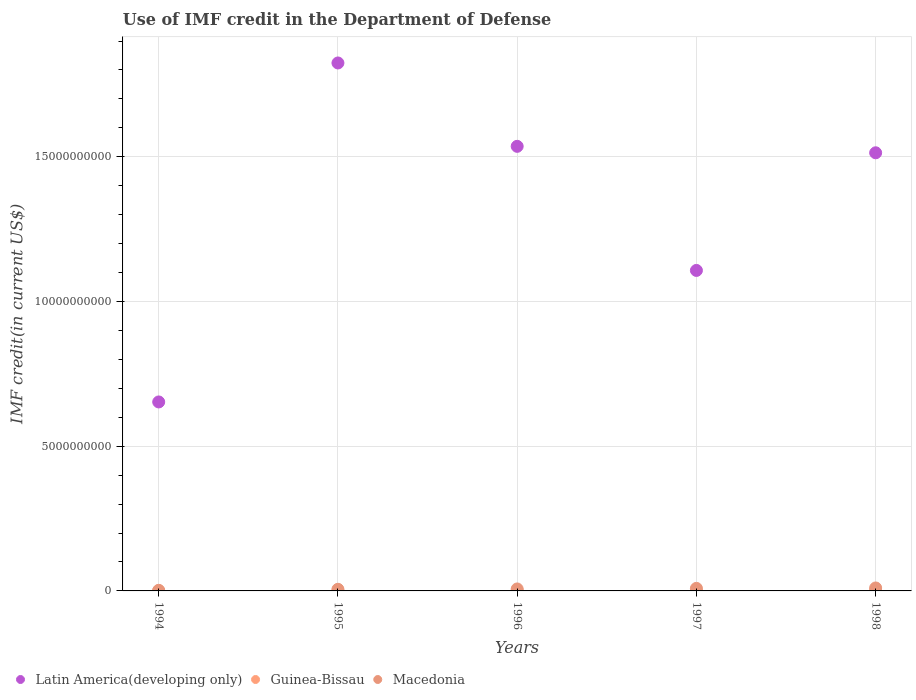How many different coloured dotlines are there?
Give a very brief answer. 3. What is the IMF credit in the Department of Defense in Latin America(developing only) in 1998?
Your answer should be very brief. 1.51e+1. Across all years, what is the maximum IMF credit in the Department of Defense in Guinea-Bissau?
Your answer should be compact. 1.54e+07. Across all years, what is the minimum IMF credit in the Department of Defense in Latin America(developing only)?
Ensure brevity in your answer.  6.53e+09. What is the total IMF credit in the Department of Defense in Latin America(developing only) in the graph?
Offer a terse response. 6.63e+1. What is the difference between the IMF credit in the Department of Defense in Guinea-Bissau in 1994 and that in 1997?
Ensure brevity in your answer.  -7.60e+06. What is the difference between the IMF credit in the Department of Defense in Guinea-Bissau in 1998 and the IMF credit in the Department of Defense in Latin America(developing only) in 1994?
Provide a short and direct response. -6.51e+09. What is the average IMF credit in the Department of Defense in Latin America(developing only) per year?
Offer a very short reply. 1.33e+1. In the year 1995, what is the difference between the IMF credit in the Department of Defense in Macedonia and IMF credit in the Department of Defense in Latin America(developing only)?
Your response must be concise. -1.82e+1. What is the ratio of the IMF credit in the Department of Defense in Guinea-Bissau in 1994 to that in 1995?
Provide a succinct answer. 0.78. Is the IMF credit in the Department of Defense in Macedonia in 1995 less than that in 1998?
Offer a terse response. Yes. Is the difference between the IMF credit in the Department of Defense in Macedonia in 1995 and 1997 greater than the difference between the IMF credit in the Department of Defense in Latin America(developing only) in 1995 and 1997?
Make the answer very short. No. What is the difference between the highest and the second highest IMF credit in the Department of Defense in Latin America(developing only)?
Offer a very short reply. 2.88e+09. What is the difference between the highest and the lowest IMF credit in the Department of Defense in Guinea-Bissau?
Offer a terse response. 1.08e+07. Is the sum of the IMF credit in the Department of Defense in Macedonia in 1995 and 1997 greater than the maximum IMF credit in the Department of Defense in Latin America(developing only) across all years?
Keep it short and to the point. No. Does the IMF credit in the Department of Defense in Macedonia monotonically increase over the years?
Keep it short and to the point. Yes. Is the IMF credit in the Department of Defense in Guinea-Bissau strictly greater than the IMF credit in the Department of Defense in Macedonia over the years?
Give a very brief answer. No. Is the IMF credit in the Department of Defense in Guinea-Bissau strictly less than the IMF credit in the Department of Defense in Macedonia over the years?
Offer a very short reply. Yes. How many years are there in the graph?
Make the answer very short. 5. Are the values on the major ticks of Y-axis written in scientific E-notation?
Provide a succinct answer. No. Does the graph contain any zero values?
Make the answer very short. No. Does the graph contain grids?
Provide a succinct answer. Yes. Where does the legend appear in the graph?
Make the answer very short. Bottom left. What is the title of the graph?
Keep it short and to the point. Use of IMF credit in the Department of Defense. What is the label or title of the Y-axis?
Ensure brevity in your answer.  IMF credit(in current US$). What is the IMF credit(in current US$) of Latin America(developing only) in 1994?
Ensure brevity in your answer.  6.53e+09. What is the IMF credit(in current US$) in Guinea-Bissau in 1994?
Offer a very short reply. 4.60e+06. What is the IMF credit(in current US$) in Macedonia in 1994?
Your answer should be very brief. 2.05e+07. What is the IMF credit(in current US$) in Latin America(developing only) in 1995?
Your answer should be compact. 1.82e+1. What is the IMF credit(in current US$) in Guinea-Bissau in 1995?
Give a very brief answer. 5.91e+06. What is the IMF credit(in current US$) in Macedonia in 1995?
Make the answer very short. 5.66e+07. What is the IMF credit(in current US$) in Latin America(developing only) in 1996?
Your answer should be compact. 1.54e+1. What is the IMF credit(in current US$) in Guinea-Bissau in 1996?
Keep it short and to the point. 7.66e+06. What is the IMF credit(in current US$) of Macedonia in 1996?
Provide a short and direct response. 6.82e+07. What is the IMF credit(in current US$) of Latin America(developing only) in 1997?
Give a very brief answer. 1.11e+1. What is the IMF credit(in current US$) in Guinea-Bissau in 1997?
Your response must be concise. 1.22e+07. What is the IMF credit(in current US$) in Macedonia in 1997?
Ensure brevity in your answer.  8.81e+07. What is the IMF credit(in current US$) in Latin America(developing only) in 1998?
Provide a succinct answer. 1.51e+1. What is the IMF credit(in current US$) in Guinea-Bissau in 1998?
Your answer should be very brief. 1.54e+07. What is the IMF credit(in current US$) of Macedonia in 1998?
Ensure brevity in your answer.  1.02e+08. Across all years, what is the maximum IMF credit(in current US$) in Latin America(developing only)?
Give a very brief answer. 1.82e+1. Across all years, what is the maximum IMF credit(in current US$) of Guinea-Bissau?
Give a very brief answer. 1.54e+07. Across all years, what is the maximum IMF credit(in current US$) of Macedonia?
Offer a terse response. 1.02e+08. Across all years, what is the minimum IMF credit(in current US$) of Latin America(developing only)?
Your answer should be very brief. 6.53e+09. Across all years, what is the minimum IMF credit(in current US$) of Guinea-Bissau?
Your answer should be very brief. 4.60e+06. Across all years, what is the minimum IMF credit(in current US$) in Macedonia?
Your response must be concise. 2.05e+07. What is the total IMF credit(in current US$) of Latin America(developing only) in the graph?
Provide a succinct answer. 6.63e+1. What is the total IMF credit(in current US$) of Guinea-Bissau in the graph?
Your answer should be very brief. 4.58e+07. What is the total IMF credit(in current US$) in Macedonia in the graph?
Ensure brevity in your answer.  3.36e+08. What is the difference between the IMF credit(in current US$) of Latin America(developing only) in 1994 and that in 1995?
Offer a very short reply. -1.17e+1. What is the difference between the IMF credit(in current US$) in Guinea-Bissau in 1994 and that in 1995?
Make the answer very short. -1.31e+06. What is the difference between the IMF credit(in current US$) in Macedonia in 1994 and that in 1995?
Make the answer very short. -3.61e+07. What is the difference between the IMF credit(in current US$) in Latin America(developing only) in 1994 and that in 1996?
Give a very brief answer. -8.83e+09. What is the difference between the IMF credit(in current US$) in Guinea-Bissau in 1994 and that in 1996?
Your response must be concise. -3.06e+06. What is the difference between the IMF credit(in current US$) in Macedonia in 1994 and that in 1996?
Ensure brevity in your answer.  -4.77e+07. What is the difference between the IMF credit(in current US$) of Latin America(developing only) in 1994 and that in 1997?
Offer a very short reply. -4.54e+09. What is the difference between the IMF credit(in current US$) in Guinea-Bissau in 1994 and that in 1997?
Ensure brevity in your answer.  -7.60e+06. What is the difference between the IMF credit(in current US$) in Macedonia in 1994 and that in 1997?
Provide a succinct answer. -6.76e+07. What is the difference between the IMF credit(in current US$) of Latin America(developing only) in 1994 and that in 1998?
Your response must be concise. -8.61e+09. What is the difference between the IMF credit(in current US$) in Guinea-Bissau in 1994 and that in 1998?
Offer a very short reply. -1.08e+07. What is the difference between the IMF credit(in current US$) in Macedonia in 1994 and that in 1998?
Make the answer very short. -8.19e+07. What is the difference between the IMF credit(in current US$) of Latin America(developing only) in 1995 and that in 1996?
Ensure brevity in your answer.  2.88e+09. What is the difference between the IMF credit(in current US$) in Guinea-Bissau in 1995 and that in 1996?
Give a very brief answer. -1.75e+06. What is the difference between the IMF credit(in current US$) of Macedonia in 1995 and that in 1996?
Offer a terse response. -1.15e+07. What is the difference between the IMF credit(in current US$) of Latin America(developing only) in 1995 and that in 1997?
Offer a terse response. 7.17e+09. What is the difference between the IMF credit(in current US$) in Guinea-Bissau in 1995 and that in 1997?
Keep it short and to the point. -6.29e+06. What is the difference between the IMF credit(in current US$) in Macedonia in 1995 and that in 1997?
Provide a succinct answer. -3.15e+07. What is the difference between the IMF credit(in current US$) in Latin America(developing only) in 1995 and that in 1998?
Provide a short and direct response. 3.10e+09. What is the difference between the IMF credit(in current US$) of Guinea-Bissau in 1995 and that in 1998?
Ensure brevity in your answer.  -9.51e+06. What is the difference between the IMF credit(in current US$) in Macedonia in 1995 and that in 1998?
Offer a very short reply. -4.58e+07. What is the difference between the IMF credit(in current US$) of Latin America(developing only) in 1996 and that in 1997?
Ensure brevity in your answer.  4.29e+09. What is the difference between the IMF credit(in current US$) in Guinea-Bissau in 1996 and that in 1997?
Your answer should be compact. -4.54e+06. What is the difference between the IMF credit(in current US$) in Macedonia in 1996 and that in 1997?
Keep it short and to the point. -1.99e+07. What is the difference between the IMF credit(in current US$) of Latin America(developing only) in 1996 and that in 1998?
Make the answer very short. 2.23e+08. What is the difference between the IMF credit(in current US$) of Guinea-Bissau in 1996 and that in 1998?
Ensure brevity in your answer.  -7.76e+06. What is the difference between the IMF credit(in current US$) in Macedonia in 1996 and that in 1998?
Offer a very short reply. -3.42e+07. What is the difference between the IMF credit(in current US$) in Latin America(developing only) in 1997 and that in 1998?
Provide a short and direct response. -4.06e+09. What is the difference between the IMF credit(in current US$) in Guinea-Bissau in 1997 and that in 1998?
Offer a very short reply. -3.22e+06. What is the difference between the IMF credit(in current US$) of Macedonia in 1997 and that in 1998?
Your answer should be compact. -1.43e+07. What is the difference between the IMF credit(in current US$) in Latin America(developing only) in 1994 and the IMF credit(in current US$) in Guinea-Bissau in 1995?
Provide a short and direct response. 6.52e+09. What is the difference between the IMF credit(in current US$) in Latin America(developing only) in 1994 and the IMF credit(in current US$) in Macedonia in 1995?
Ensure brevity in your answer.  6.47e+09. What is the difference between the IMF credit(in current US$) in Guinea-Bissau in 1994 and the IMF credit(in current US$) in Macedonia in 1995?
Keep it short and to the point. -5.20e+07. What is the difference between the IMF credit(in current US$) of Latin America(developing only) in 1994 and the IMF credit(in current US$) of Guinea-Bissau in 1996?
Your answer should be compact. 6.52e+09. What is the difference between the IMF credit(in current US$) of Latin America(developing only) in 1994 and the IMF credit(in current US$) of Macedonia in 1996?
Your answer should be compact. 6.46e+09. What is the difference between the IMF credit(in current US$) in Guinea-Bissau in 1994 and the IMF credit(in current US$) in Macedonia in 1996?
Offer a very short reply. -6.36e+07. What is the difference between the IMF credit(in current US$) of Latin America(developing only) in 1994 and the IMF credit(in current US$) of Guinea-Bissau in 1997?
Provide a short and direct response. 6.52e+09. What is the difference between the IMF credit(in current US$) of Latin America(developing only) in 1994 and the IMF credit(in current US$) of Macedonia in 1997?
Make the answer very short. 6.44e+09. What is the difference between the IMF credit(in current US$) of Guinea-Bissau in 1994 and the IMF credit(in current US$) of Macedonia in 1997?
Your answer should be compact. -8.35e+07. What is the difference between the IMF credit(in current US$) of Latin America(developing only) in 1994 and the IMF credit(in current US$) of Guinea-Bissau in 1998?
Offer a terse response. 6.51e+09. What is the difference between the IMF credit(in current US$) of Latin America(developing only) in 1994 and the IMF credit(in current US$) of Macedonia in 1998?
Your response must be concise. 6.43e+09. What is the difference between the IMF credit(in current US$) of Guinea-Bissau in 1994 and the IMF credit(in current US$) of Macedonia in 1998?
Offer a terse response. -9.78e+07. What is the difference between the IMF credit(in current US$) of Latin America(developing only) in 1995 and the IMF credit(in current US$) of Guinea-Bissau in 1996?
Offer a terse response. 1.82e+1. What is the difference between the IMF credit(in current US$) of Latin America(developing only) in 1995 and the IMF credit(in current US$) of Macedonia in 1996?
Offer a terse response. 1.82e+1. What is the difference between the IMF credit(in current US$) of Guinea-Bissau in 1995 and the IMF credit(in current US$) of Macedonia in 1996?
Offer a terse response. -6.22e+07. What is the difference between the IMF credit(in current US$) in Latin America(developing only) in 1995 and the IMF credit(in current US$) in Guinea-Bissau in 1997?
Your response must be concise. 1.82e+1. What is the difference between the IMF credit(in current US$) of Latin America(developing only) in 1995 and the IMF credit(in current US$) of Macedonia in 1997?
Ensure brevity in your answer.  1.82e+1. What is the difference between the IMF credit(in current US$) of Guinea-Bissau in 1995 and the IMF credit(in current US$) of Macedonia in 1997?
Your answer should be very brief. -8.22e+07. What is the difference between the IMF credit(in current US$) of Latin America(developing only) in 1995 and the IMF credit(in current US$) of Guinea-Bissau in 1998?
Provide a short and direct response. 1.82e+1. What is the difference between the IMF credit(in current US$) in Latin America(developing only) in 1995 and the IMF credit(in current US$) in Macedonia in 1998?
Keep it short and to the point. 1.81e+1. What is the difference between the IMF credit(in current US$) in Guinea-Bissau in 1995 and the IMF credit(in current US$) in Macedonia in 1998?
Your answer should be very brief. -9.65e+07. What is the difference between the IMF credit(in current US$) in Latin America(developing only) in 1996 and the IMF credit(in current US$) in Guinea-Bissau in 1997?
Give a very brief answer. 1.53e+1. What is the difference between the IMF credit(in current US$) of Latin America(developing only) in 1996 and the IMF credit(in current US$) of Macedonia in 1997?
Your response must be concise. 1.53e+1. What is the difference between the IMF credit(in current US$) of Guinea-Bissau in 1996 and the IMF credit(in current US$) of Macedonia in 1997?
Keep it short and to the point. -8.04e+07. What is the difference between the IMF credit(in current US$) in Latin America(developing only) in 1996 and the IMF credit(in current US$) in Guinea-Bissau in 1998?
Make the answer very short. 1.53e+1. What is the difference between the IMF credit(in current US$) of Latin America(developing only) in 1996 and the IMF credit(in current US$) of Macedonia in 1998?
Offer a very short reply. 1.53e+1. What is the difference between the IMF credit(in current US$) in Guinea-Bissau in 1996 and the IMF credit(in current US$) in Macedonia in 1998?
Your answer should be compact. -9.47e+07. What is the difference between the IMF credit(in current US$) of Latin America(developing only) in 1997 and the IMF credit(in current US$) of Guinea-Bissau in 1998?
Provide a succinct answer. 1.11e+1. What is the difference between the IMF credit(in current US$) of Latin America(developing only) in 1997 and the IMF credit(in current US$) of Macedonia in 1998?
Make the answer very short. 1.10e+1. What is the difference between the IMF credit(in current US$) in Guinea-Bissau in 1997 and the IMF credit(in current US$) in Macedonia in 1998?
Provide a succinct answer. -9.02e+07. What is the average IMF credit(in current US$) of Latin America(developing only) per year?
Provide a succinct answer. 1.33e+1. What is the average IMF credit(in current US$) in Guinea-Bissau per year?
Your answer should be compact. 9.16e+06. What is the average IMF credit(in current US$) of Macedonia per year?
Make the answer very short. 6.71e+07. In the year 1994, what is the difference between the IMF credit(in current US$) of Latin America(developing only) and IMF credit(in current US$) of Guinea-Bissau?
Give a very brief answer. 6.52e+09. In the year 1994, what is the difference between the IMF credit(in current US$) in Latin America(developing only) and IMF credit(in current US$) in Macedonia?
Give a very brief answer. 6.51e+09. In the year 1994, what is the difference between the IMF credit(in current US$) in Guinea-Bissau and IMF credit(in current US$) in Macedonia?
Offer a terse response. -1.59e+07. In the year 1995, what is the difference between the IMF credit(in current US$) in Latin America(developing only) and IMF credit(in current US$) in Guinea-Bissau?
Your answer should be compact. 1.82e+1. In the year 1995, what is the difference between the IMF credit(in current US$) in Latin America(developing only) and IMF credit(in current US$) in Macedonia?
Your answer should be very brief. 1.82e+1. In the year 1995, what is the difference between the IMF credit(in current US$) of Guinea-Bissau and IMF credit(in current US$) of Macedonia?
Your answer should be compact. -5.07e+07. In the year 1996, what is the difference between the IMF credit(in current US$) in Latin America(developing only) and IMF credit(in current US$) in Guinea-Bissau?
Provide a short and direct response. 1.54e+1. In the year 1996, what is the difference between the IMF credit(in current US$) in Latin America(developing only) and IMF credit(in current US$) in Macedonia?
Provide a short and direct response. 1.53e+1. In the year 1996, what is the difference between the IMF credit(in current US$) in Guinea-Bissau and IMF credit(in current US$) in Macedonia?
Offer a very short reply. -6.05e+07. In the year 1997, what is the difference between the IMF credit(in current US$) of Latin America(developing only) and IMF credit(in current US$) of Guinea-Bissau?
Your answer should be compact. 1.11e+1. In the year 1997, what is the difference between the IMF credit(in current US$) of Latin America(developing only) and IMF credit(in current US$) of Macedonia?
Your answer should be compact. 1.10e+1. In the year 1997, what is the difference between the IMF credit(in current US$) of Guinea-Bissau and IMF credit(in current US$) of Macedonia?
Your answer should be very brief. -7.59e+07. In the year 1998, what is the difference between the IMF credit(in current US$) of Latin America(developing only) and IMF credit(in current US$) of Guinea-Bissau?
Provide a short and direct response. 1.51e+1. In the year 1998, what is the difference between the IMF credit(in current US$) in Latin America(developing only) and IMF credit(in current US$) in Macedonia?
Provide a succinct answer. 1.50e+1. In the year 1998, what is the difference between the IMF credit(in current US$) of Guinea-Bissau and IMF credit(in current US$) of Macedonia?
Your answer should be very brief. -8.70e+07. What is the ratio of the IMF credit(in current US$) of Latin America(developing only) in 1994 to that in 1995?
Ensure brevity in your answer.  0.36. What is the ratio of the IMF credit(in current US$) of Guinea-Bissau in 1994 to that in 1995?
Keep it short and to the point. 0.78. What is the ratio of the IMF credit(in current US$) of Macedonia in 1994 to that in 1995?
Offer a very short reply. 0.36. What is the ratio of the IMF credit(in current US$) of Latin America(developing only) in 1994 to that in 1996?
Keep it short and to the point. 0.42. What is the ratio of the IMF credit(in current US$) in Guinea-Bissau in 1994 to that in 1996?
Offer a very short reply. 0.6. What is the ratio of the IMF credit(in current US$) of Macedonia in 1994 to that in 1996?
Give a very brief answer. 0.3. What is the ratio of the IMF credit(in current US$) of Latin America(developing only) in 1994 to that in 1997?
Your response must be concise. 0.59. What is the ratio of the IMF credit(in current US$) in Guinea-Bissau in 1994 to that in 1997?
Provide a succinct answer. 0.38. What is the ratio of the IMF credit(in current US$) of Macedonia in 1994 to that in 1997?
Your answer should be very brief. 0.23. What is the ratio of the IMF credit(in current US$) of Latin America(developing only) in 1994 to that in 1998?
Ensure brevity in your answer.  0.43. What is the ratio of the IMF credit(in current US$) of Guinea-Bissau in 1994 to that in 1998?
Offer a very short reply. 0.3. What is the ratio of the IMF credit(in current US$) in Macedonia in 1994 to that in 1998?
Offer a very short reply. 0.2. What is the ratio of the IMF credit(in current US$) of Latin America(developing only) in 1995 to that in 1996?
Make the answer very short. 1.19. What is the ratio of the IMF credit(in current US$) in Guinea-Bissau in 1995 to that in 1996?
Offer a very short reply. 0.77. What is the ratio of the IMF credit(in current US$) of Macedonia in 1995 to that in 1996?
Your response must be concise. 0.83. What is the ratio of the IMF credit(in current US$) of Latin America(developing only) in 1995 to that in 1997?
Keep it short and to the point. 1.65. What is the ratio of the IMF credit(in current US$) of Guinea-Bissau in 1995 to that in 1997?
Offer a terse response. 0.48. What is the ratio of the IMF credit(in current US$) of Macedonia in 1995 to that in 1997?
Offer a terse response. 0.64. What is the ratio of the IMF credit(in current US$) of Latin America(developing only) in 1995 to that in 1998?
Keep it short and to the point. 1.21. What is the ratio of the IMF credit(in current US$) in Guinea-Bissau in 1995 to that in 1998?
Offer a very short reply. 0.38. What is the ratio of the IMF credit(in current US$) of Macedonia in 1995 to that in 1998?
Offer a terse response. 0.55. What is the ratio of the IMF credit(in current US$) of Latin America(developing only) in 1996 to that in 1997?
Your response must be concise. 1.39. What is the ratio of the IMF credit(in current US$) in Guinea-Bissau in 1996 to that in 1997?
Provide a short and direct response. 0.63. What is the ratio of the IMF credit(in current US$) in Macedonia in 1996 to that in 1997?
Provide a succinct answer. 0.77. What is the ratio of the IMF credit(in current US$) in Latin America(developing only) in 1996 to that in 1998?
Ensure brevity in your answer.  1.01. What is the ratio of the IMF credit(in current US$) of Guinea-Bissau in 1996 to that in 1998?
Your response must be concise. 0.5. What is the ratio of the IMF credit(in current US$) in Macedonia in 1996 to that in 1998?
Provide a short and direct response. 0.67. What is the ratio of the IMF credit(in current US$) of Latin America(developing only) in 1997 to that in 1998?
Ensure brevity in your answer.  0.73. What is the ratio of the IMF credit(in current US$) in Guinea-Bissau in 1997 to that in 1998?
Provide a short and direct response. 0.79. What is the ratio of the IMF credit(in current US$) of Macedonia in 1997 to that in 1998?
Offer a very short reply. 0.86. What is the difference between the highest and the second highest IMF credit(in current US$) in Latin America(developing only)?
Make the answer very short. 2.88e+09. What is the difference between the highest and the second highest IMF credit(in current US$) of Guinea-Bissau?
Give a very brief answer. 3.22e+06. What is the difference between the highest and the second highest IMF credit(in current US$) in Macedonia?
Offer a terse response. 1.43e+07. What is the difference between the highest and the lowest IMF credit(in current US$) in Latin America(developing only)?
Your answer should be very brief. 1.17e+1. What is the difference between the highest and the lowest IMF credit(in current US$) in Guinea-Bissau?
Your answer should be very brief. 1.08e+07. What is the difference between the highest and the lowest IMF credit(in current US$) of Macedonia?
Ensure brevity in your answer.  8.19e+07. 